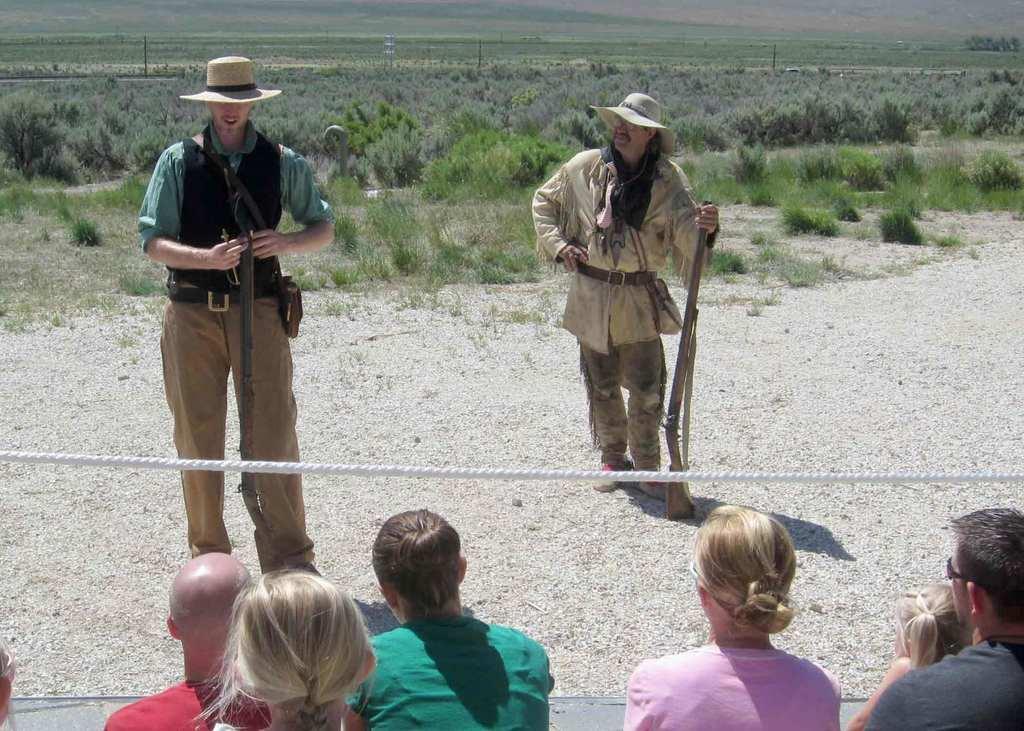In one or two sentences, can you explain what this image depicts? In this image we can see two persons are standing on the ground and they are holding guns with their hands. Here we can see a rope. At the bottom of the image we can see few people. In the background we can see grass, plants, and poles. 